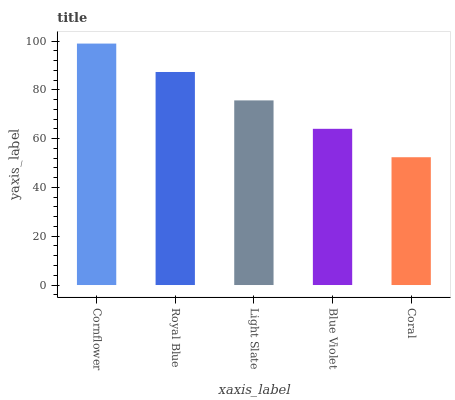Is Coral the minimum?
Answer yes or no. Yes. Is Cornflower the maximum?
Answer yes or no. Yes. Is Royal Blue the minimum?
Answer yes or no. No. Is Royal Blue the maximum?
Answer yes or no. No. Is Cornflower greater than Royal Blue?
Answer yes or no. Yes. Is Royal Blue less than Cornflower?
Answer yes or no. Yes. Is Royal Blue greater than Cornflower?
Answer yes or no. No. Is Cornflower less than Royal Blue?
Answer yes or no. No. Is Light Slate the high median?
Answer yes or no. Yes. Is Light Slate the low median?
Answer yes or no. Yes. Is Coral the high median?
Answer yes or no. No. Is Coral the low median?
Answer yes or no. No. 